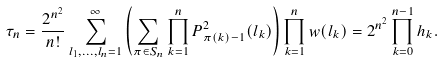Convert formula to latex. <formula><loc_0><loc_0><loc_500><loc_500>\tau _ { n } = \frac { 2 ^ { n ^ { 2 } } } { n ! } \sum _ { l _ { 1 } , \dots , l _ { n } = 1 } ^ { \infty } \left ( \sum _ { \pi \in S _ { n } } \prod _ { k = 1 } ^ { n } P _ { \pi ( k ) - 1 } ^ { 2 } ( l _ { k } ) \right ) \prod _ { k = 1 } ^ { n } w ( l _ { k } ) = 2 ^ { n ^ { 2 } } \prod _ { k = 0 } ^ { n - 1 } h _ { k } .</formula> 